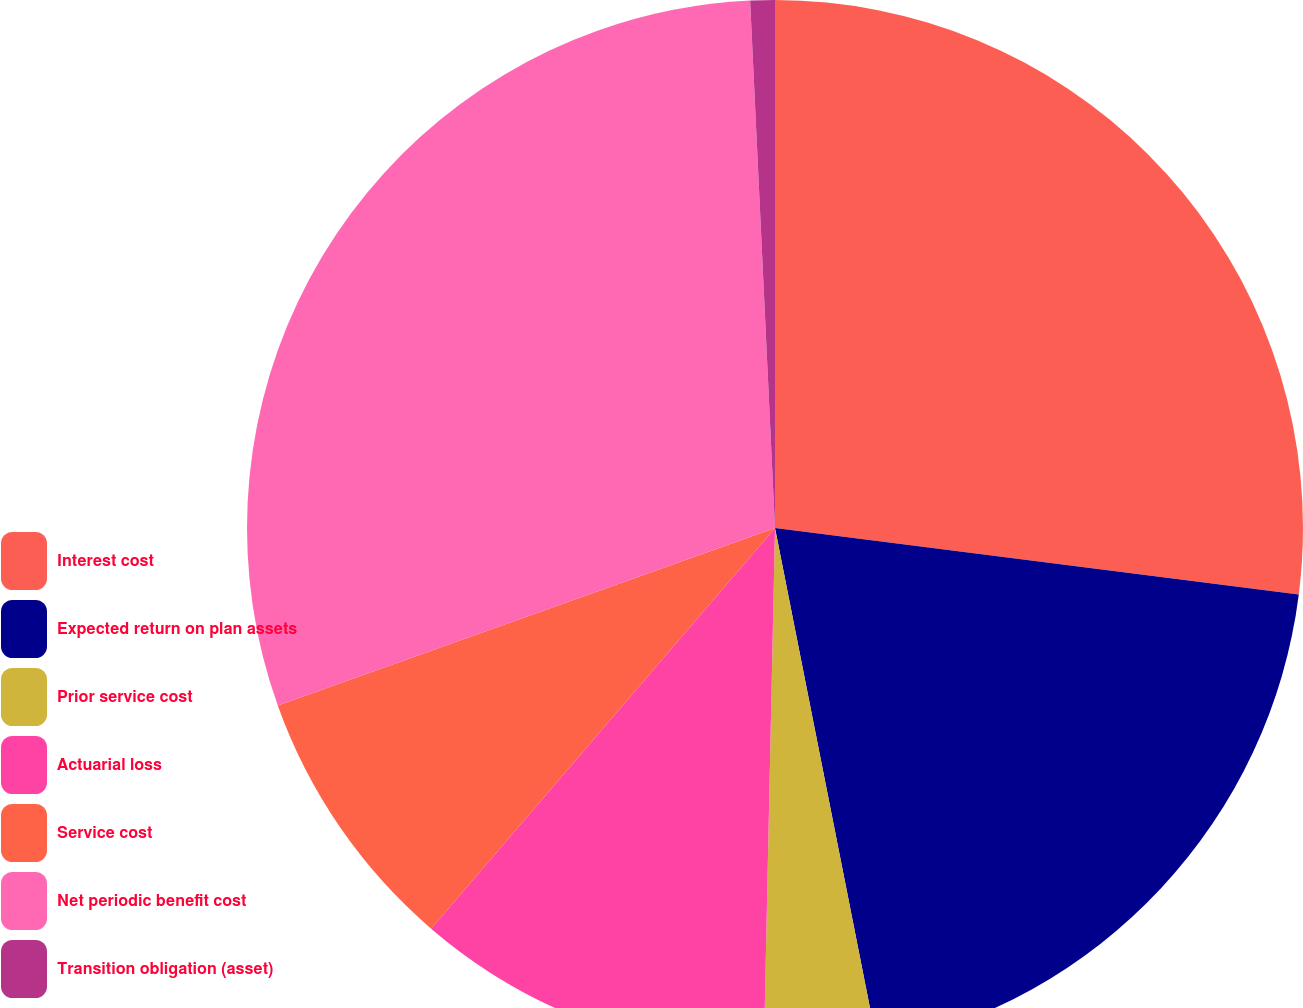Convert chart to OTSL. <chart><loc_0><loc_0><loc_500><loc_500><pie_chart><fcel>Interest cost<fcel>Expected return on plan assets<fcel>Prior service cost<fcel>Actuarial loss<fcel>Service cost<fcel>Net periodic benefit cost<fcel>Transition obligation (asset)<nl><fcel>27.01%<fcel>19.88%<fcel>3.45%<fcel>10.95%<fcel>8.25%<fcel>29.71%<fcel>0.75%<nl></chart> 